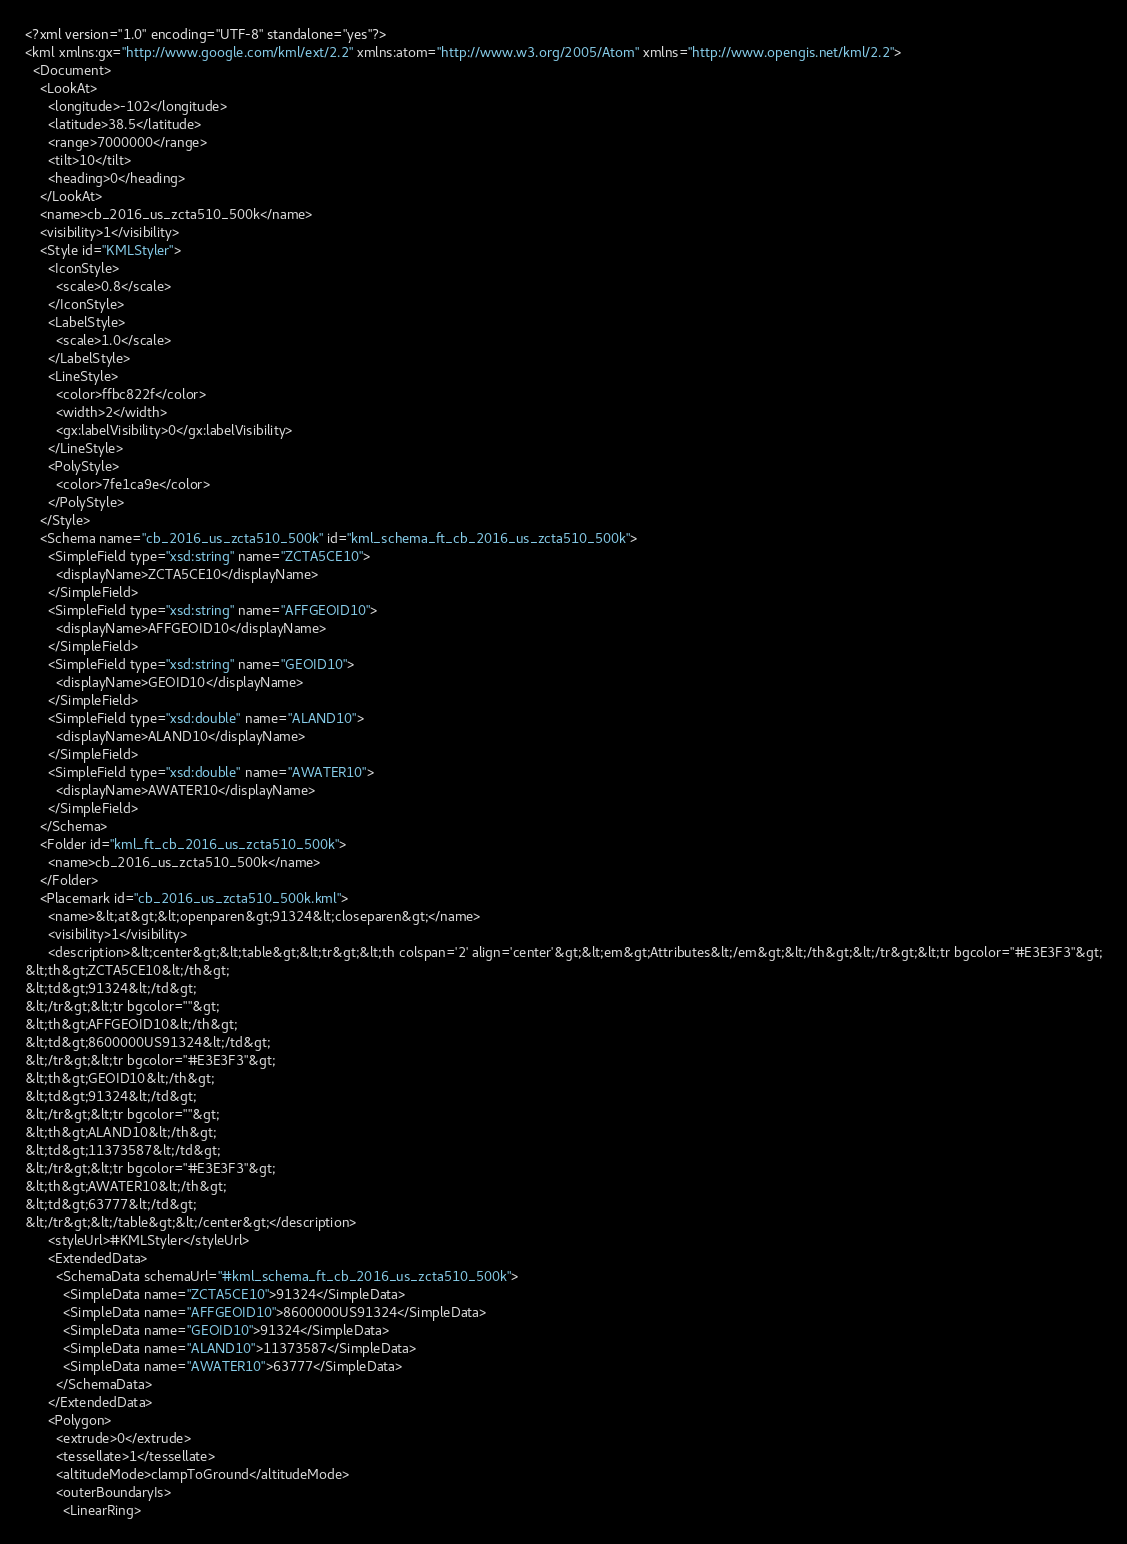Convert code to text. <code><loc_0><loc_0><loc_500><loc_500><_XML_><?xml version="1.0" encoding="UTF-8" standalone="yes"?>
<kml xmlns:gx="http://www.google.com/kml/ext/2.2" xmlns:atom="http://www.w3.org/2005/Atom" xmlns="http://www.opengis.net/kml/2.2">
  <Document>
    <LookAt>
      <longitude>-102</longitude>
      <latitude>38.5</latitude>
      <range>7000000</range>
      <tilt>10</tilt>
      <heading>0</heading>
    </LookAt>
    <name>cb_2016_us_zcta510_500k</name>
    <visibility>1</visibility>
    <Style id="KMLStyler">
      <IconStyle>
        <scale>0.8</scale>
      </IconStyle>
      <LabelStyle>
        <scale>1.0</scale>
      </LabelStyle>
      <LineStyle>
        <color>ffbc822f</color>
        <width>2</width>
        <gx:labelVisibility>0</gx:labelVisibility>
      </LineStyle>
      <PolyStyle>
        <color>7fe1ca9e</color>
      </PolyStyle>
    </Style>
    <Schema name="cb_2016_us_zcta510_500k" id="kml_schema_ft_cb_2016_us_zcta510_500k">
      <SimpleField type="xsd:string" name="ZCTA5CE10">
        <displayName>ZCTA5CE10</displayName>
      </SimpleField>
      <SimpleField type="xsd:string" name="AFFGEOID10">
        <displayName>AFFGEOID10</displayName>
      </SimpleField>
      <SimpleField type="xsd:string" name="GEOID10">
        <displayName>GEOID10</displayName>
      </SimpleField>
      <SimpleField type="xsd:double" name="ALAND10">
        <displayName>ALAND10</displayName>
      </SimpleField>
      <SimpleField type="xsd:double" name="AWATER10">
        <displayName>AWATER10</displayName>
      </SimpleField>
    </Schema>
    <Folder id="kml_ft_cb_2016_us_zcta510_500k">
      <name>cb_2016_us_zcta510_500k</name>
    </Folder>
    <Placemark id="cb_2016_us_zcta510_500k.kml">
      <name>&lt;at&gt;&lt;openparen&gt;91324&lt;closeparen&gt;</name>
      <visibility>1</visibility>
      <description>&lt;center&gt;&lt;table&gt;&lt;tr&gt;&lt;th colspan='2' align='center'&gt;&lt;em&gt;Attributes&lt;/em&gt;&lt;/th&gt;&lt;/tr&gt;&lt;tr bgcolor="#E3E3F3"&gt;
&lt;th&gt;ZCTA5CE10&lt;/th&gt;
&lt;td&gt;91324&lt;/td&gt;
&lt;/tr&gt;&lt;tr bgcolor=""&gt;
&lt;th&gt;AFFGEOID10&lt;/th&gt;
&lt;td&gt;8600000US91324&lt;/td&gt;
&lt;/tr&gt;&lt;tr bgcolor="#E3E3F3"&gt;
&lt;th&gt;GEOID10&lt;/th&gt;
&lt;td&gt;91324&lt;/td&gt;
&lt;/tr&gt;&lt;tr bgcolor=""&gt;
&lt;th&gt;ALAND10&lt;/th&gt;
&lt;td&gt;11373587&lt;/td&gt;
&lt;/tr&gt;&lt;tr bgcolor="#E3E3F3"&gt;
&lt;th&gt;AWATER10&lt;/th&gt;
&lt;td&gt;63777&lt;/td&gt;
&lt;/tr&gt;&lt;/table&gt;&lt;/center&gt;</description>
      <styleUrl>#KMLStyler</styleUrl>
      <ExtendedData>
        <SchemaData schemaUrl="#kml_schema_ft_cb_2016_us_zcta510_500k">
          <SimpleData name="ZCTA5CE10">91324</SimpleData>
          <SimpleData name="AFFGEOID10">8600000US91324</SimpleData>
          <SimpleData name="GEOID10">91324</SimpleData>
          <SimpleData name="ALAND10">11373587</SimpleData>
          <SimpleData name="AWATER10">63777</SimpleData>
        </SchemaData>
      </ExtendedData>
      <Polygon>
        <extrude>0</extrude>
        <tessellate>1</tessellate>
        <altitudeMode>clampToGround</altitudeMode>
        <outerBoundaryIs>
          <LinearRing></code> 